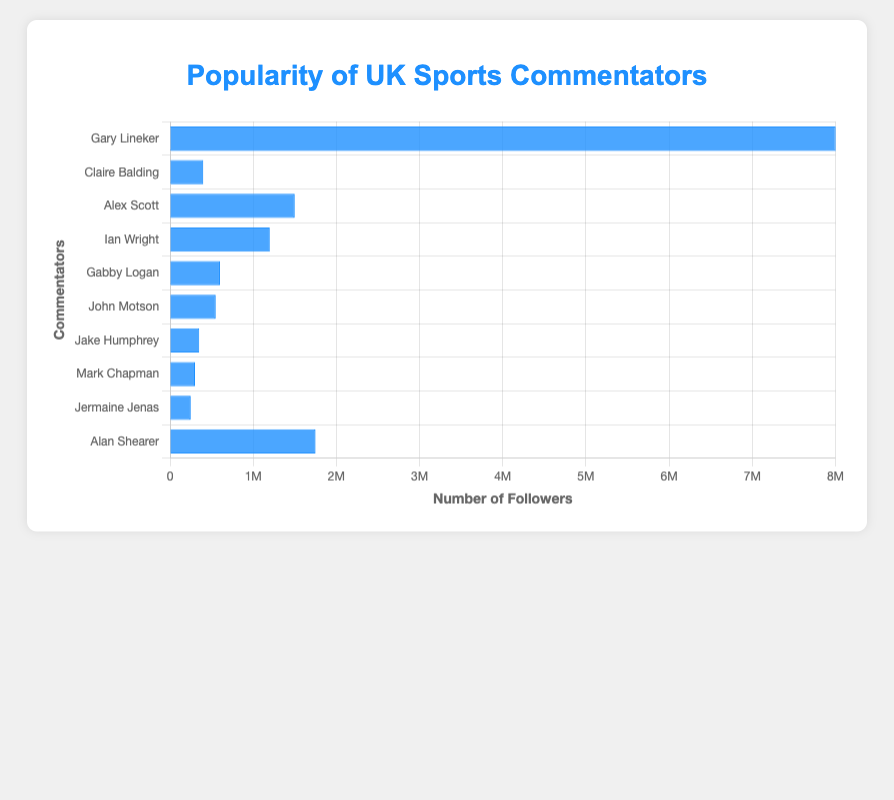Who is the most popular UK sports commentator according to social media followings? The commentator with the highest number of social media followers is the most popular. Gary Lineker has 8,000,000 followers, which is the highest.
Answer: Gary Lineker Who has more social media followers, Alex Scott or Ian Wright? To determine who has more followers, compare their numbers directly. Alex Scott has 1,500,000 followers, while Ian Wright has 1,200,000 followers.
Answer: Alex Scott What is the total number of social media followers for Gabby Logan and John Motson together? Add the followers of both commentators: Gabby Logan (600,000) + John Motson (550,000) = 1,150,000.
Answer: 1,150,000 Which commentator has the third highest number of social media followers? Arrange the commentators by the number of followers in descending order. The third highest number of followers belongs to Alan Shearer, with 1,750,000 followers.
Answer: Alan Shearer Is Jake Humphrey or Mark Chapman more popular based on social media followings? Compare Jake Humphrey's followers (350,000) with Mark Chapman's followers (300,000). Jake Humphrey has more followers.
Answer: Jake Humphrey What is the difference in social media followers between the most and least popular commentators? Subtract the followers of the least popular commentator (Jermaine Jenas, 250,000) from the most popular (Gary Lineker, 8,000,000). 8,000,000 - 250,000 = 7,750,000.
Answer: 7,750,000 How many more followers does Alan Shearer have compared to Claire Balding? Subtract Claire Balding's followers from Alan Shearer's followers: 1,750,000 - 400,000 = 1,350,000.
Answer: 1,350,000 What is the average number of social media followers among all the UK sports commentators? Add the total followers of all commentators and divide by the number of commentators (10). (8,000,000 + 400,000 + 1,500,000 + 1,200,000 + 600,000 + 550,000 + 350,000 + 300,000 + 250,000 + 1,750,000) / 10 = 1,490,000.
Answer: 1,490,000 What fraction of Gary Lineker's followers does Alex Scott have? Divide Alex Scott's followers by Gary Lineker's followers: 1,500,000 / 8,000,000 = 3/16.
Answer: 3/16 